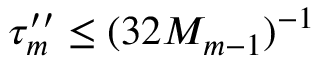Convert formula to latex. <formula><loc_0><loc_0><loc_500><loc_500>\tau _ { m } ^ { \prime \prime } \leq ( 3 2 M _ { m - 1 } ) ^ { - 1 }</formula> 